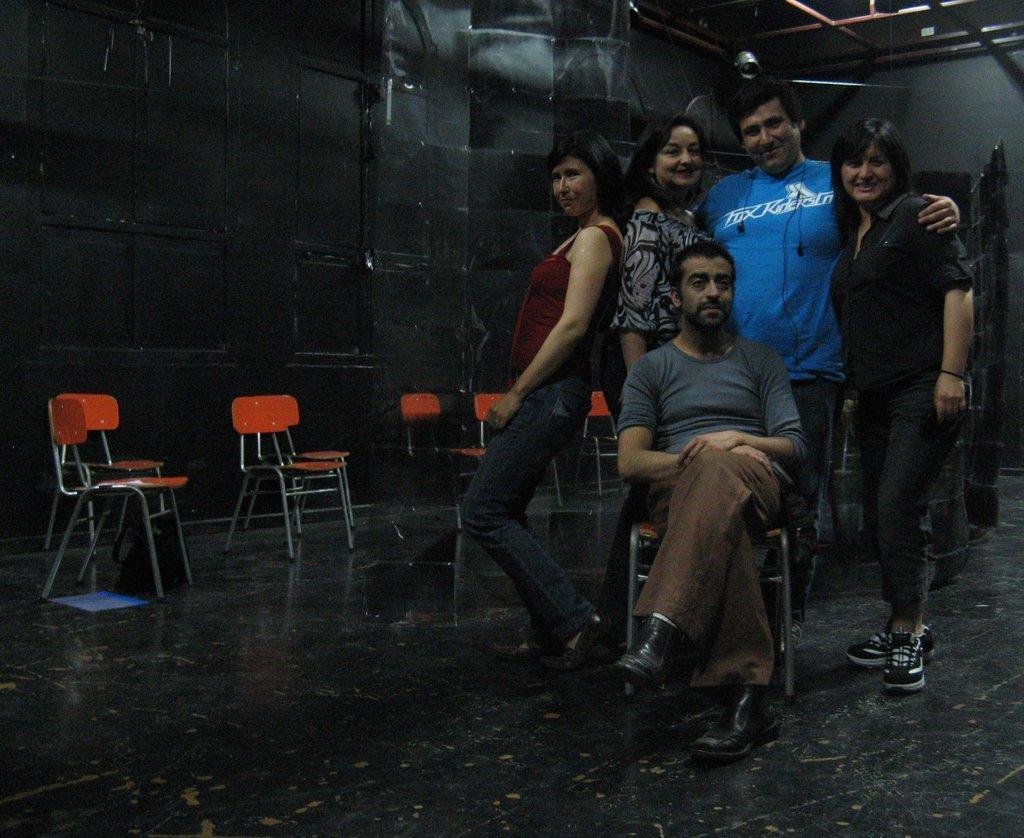In one or two sentences, can you explain what this image depicts? In the right there are four persons standing and one person is sitting on the chair. On both side orange color chairs are visible. The background is grey and black in color visible. A roof top is off rod and light visible. This image is taken inside a hall. 